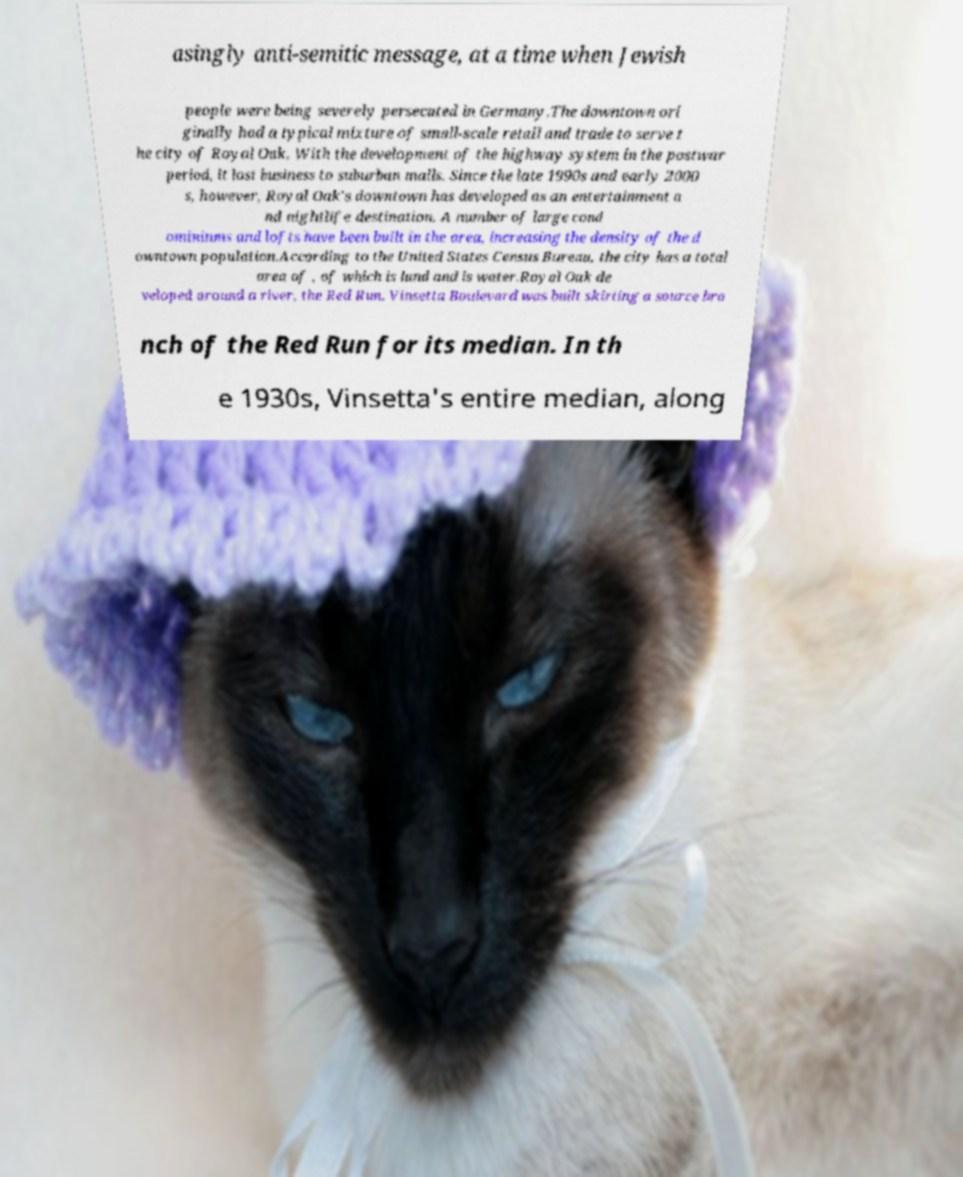For documentation purposes, I need the text within this image transcribed. Could you provide that? asingly anti-semitic message, at a time when Jewish people were being severely persecuted in Germany.The downtown ori ginally had a typical mixture of small-scale retail and trade to serve t he city of Royal Oak. With the development of the highway system in the postwar period, it lost business to suburban malls. Since the late 1990s and early 2000 s, however, Royal Oak's downtown has developed as an entertainment a nd nightlife destination. A number of large cond ominiums and lofts have been built in the area, increasing the density of the d owntown population.According to the United States Census Bureau, the city has a total area of , of which is land and is water.Royal Oak de veloped around a river, the Red Run. Vinsetta Boulevard was built skirting a source bra nch of the Red Run for its median. In th e 1930s, Vinsetta's entire median, along 